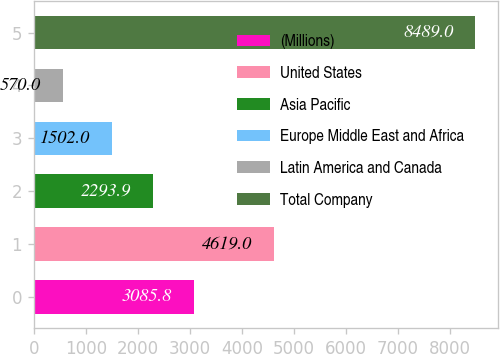<chart> <loc_0><loc_0><loc_500><loc_500><bar_chart><fcel>(Millions)<fcel>United States<fcel>Asia Pacific<fcel>Europe Middle East and Africa<fcel>Latin America and Canada<fcel>Total Company<nl><fcel>3085.8<fcel>4619<fcel>2293.9<fcel>1502<fcel>570<fcel>8489<nl></chart> 